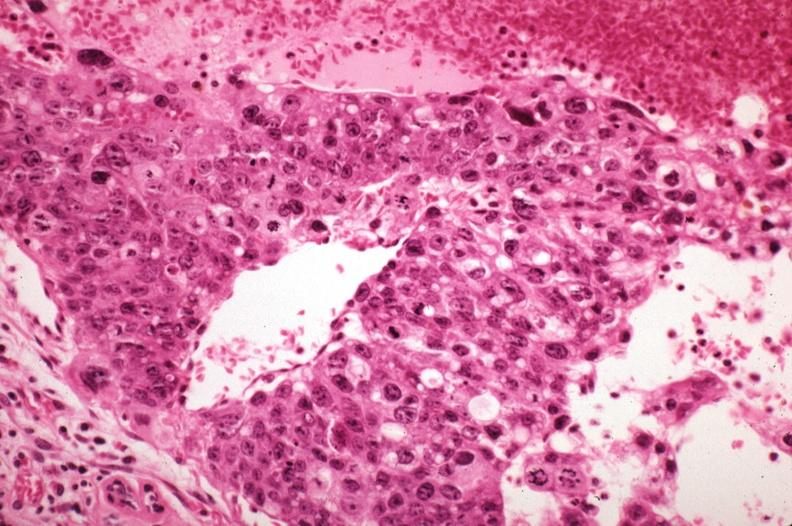how does this image show metastatic choriocarcinoma?
Answer the question using a single word or phrase. With pleomorphism 